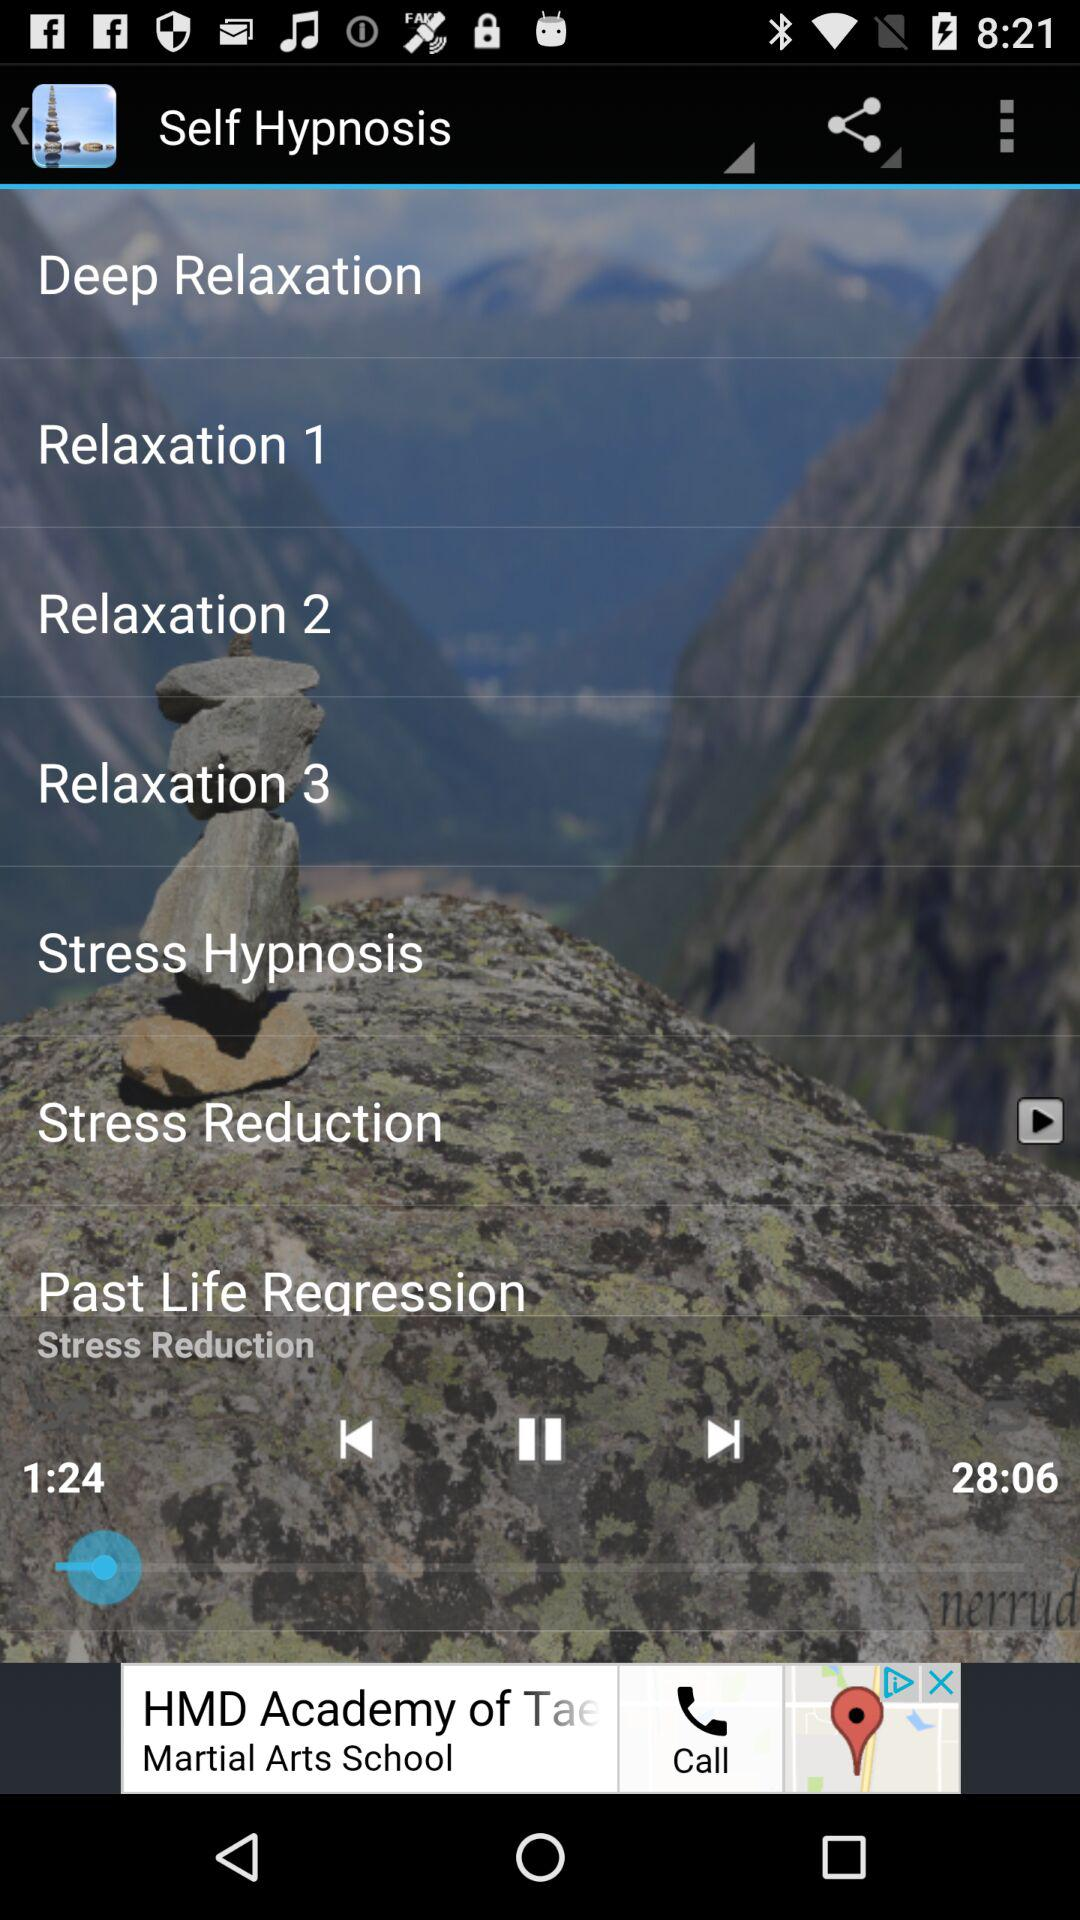What is the duration of the audio? The duration is 28 minutes 6 seconds. 